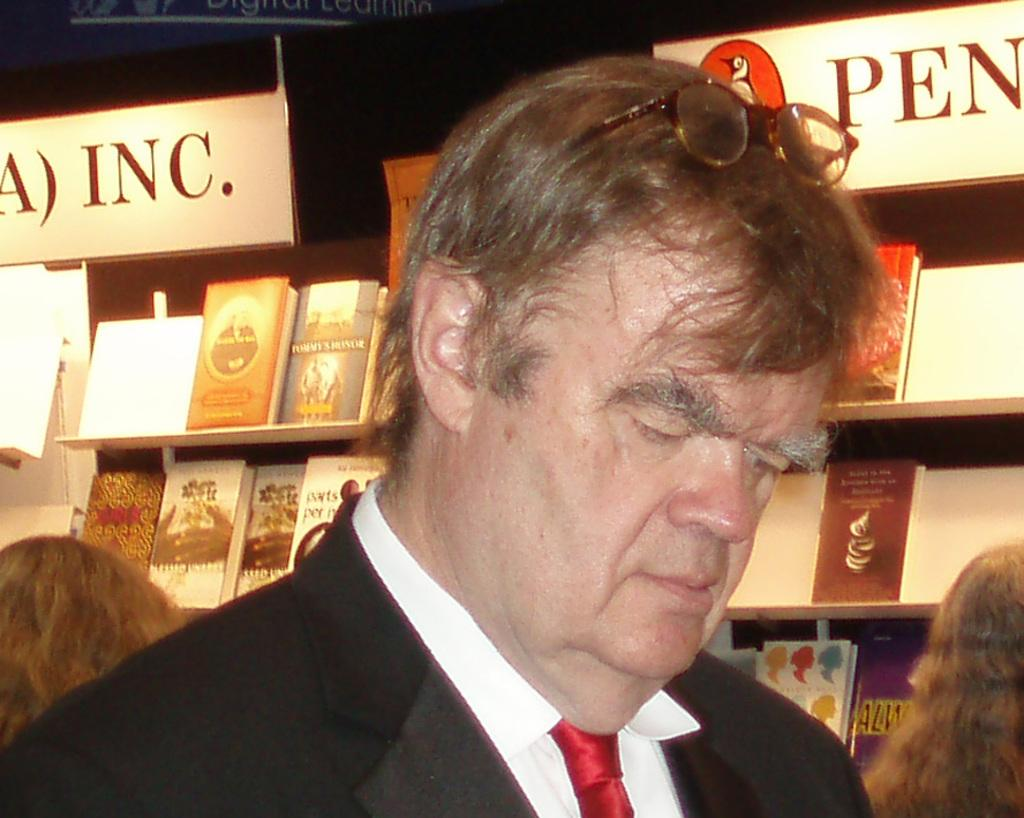How many people are present in the image? There are three persons in the image. What can be seen on the racks in the image? There are books on racks in the image. What type of objects have text written on them in the image? There are boards with text in the image. What type of flight is being advertised on the boards in the image? There are no flights or advertisements mentioned in the image; it only features books on racks and boards with text. 